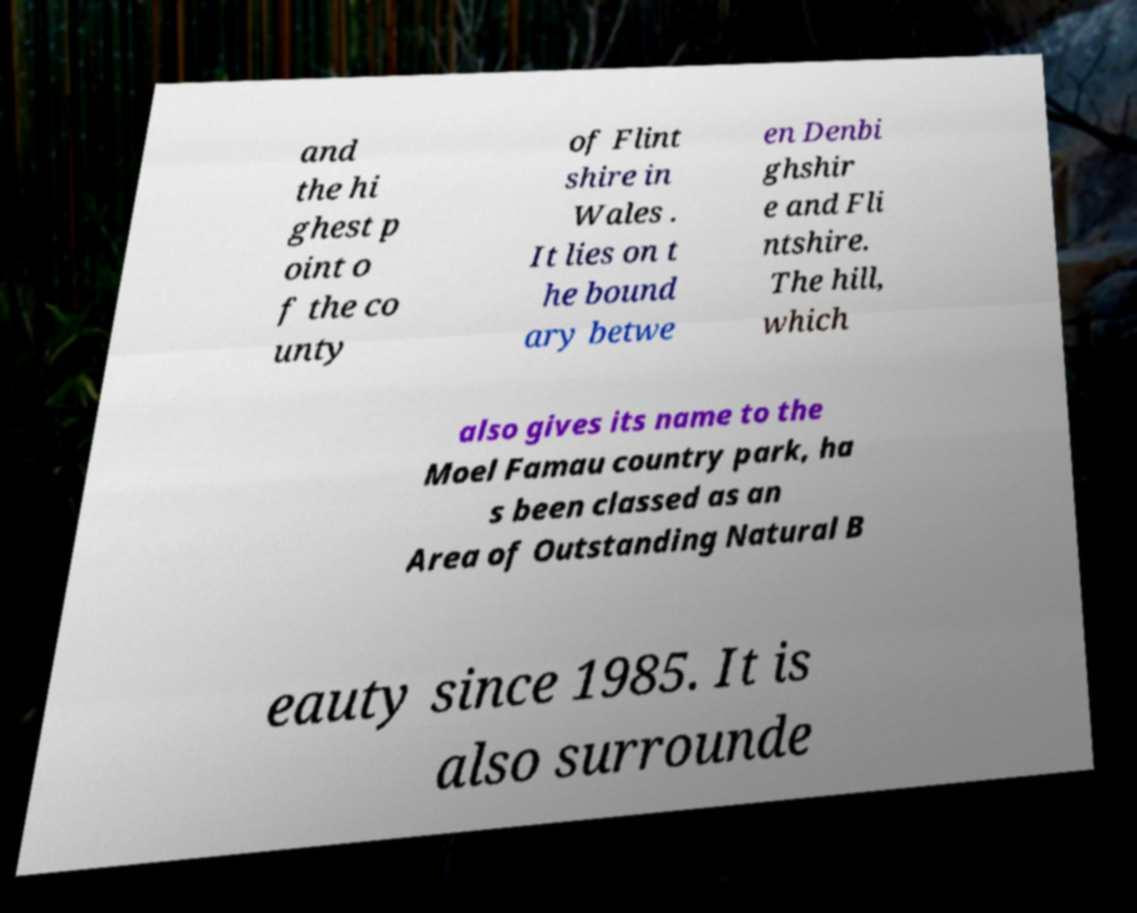Could you assist in decoding the text presented in this image and type it out clearly? and the hi ghest p oint o f the co unty of Flint shire in Wales . It lies on t he bound ary betwe en Denbi ghshir e and Fli ntshire. The hill, which also gives its name to the Moel Famau country park, ha s been classed as an Area of Outstanding Natural B eauty since 1985. It is also surrounde 